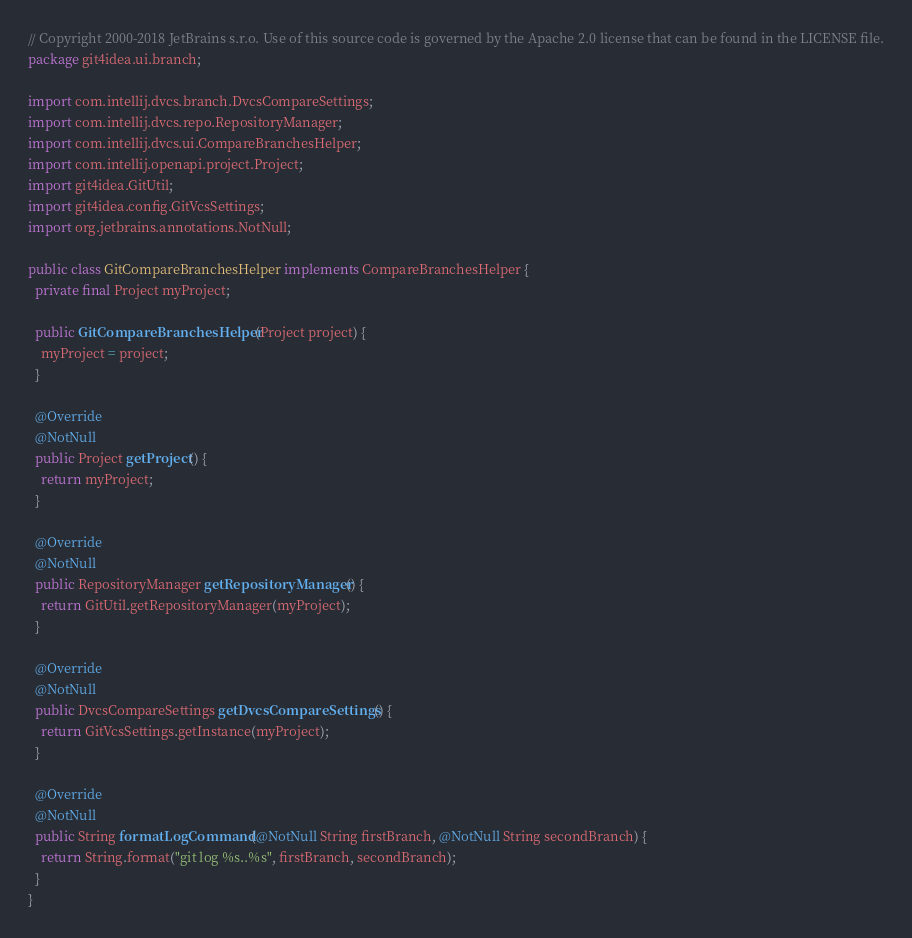<code> <loc_0><loc_0><loc_500><loc_500><_Java_>// Copyright 2000-2018 JetBrains s.r.o. Use of this source code is governed by the Apache 2.0 license that can be found in the LICENSE file.
package git4idea.ui.branch;

import com.intellij.dvcs.branch.DvcsCompareSettings;
import com.intellij.dvcs.repo.RepositoryManager;
import com.intellij.dvcs.ui.CompareBranchesHelper;
import com.intellij.openapi.project.Project;
import git4idea.GitUtil;
import git4idea.config.GitVcsSettings;
import org.jetbrains.annotations.NotNull;

public class GitCompareBranchesHelper implements CompareBranchesHelper {
  private final Project myProject;

  public GitCompareBranchesHelper(Project project) {
    myProject = project;
  }

  @Override
  @NotNull
  public Project getProject() {
    return myProject;
  }

  @Override
  @NotNull
  public RepositoryManager getRepositoryManager() {
    return GitUtil.getRepositoryManager(myProject);
  }

  @Override
  @NotNull
  public DvcsCompareSettings getDvcsCompareSettings() {
    return GitVcsSettings.getInstance(myProject);
  }

  @Override
  @NotNull
  public String formatLogCommand(@NotNull String firstBranch, @NotNull String secondBranch) {
    return String.format("git log %s..%s", firstBranch, secondBranch);
  }
}
</code> 